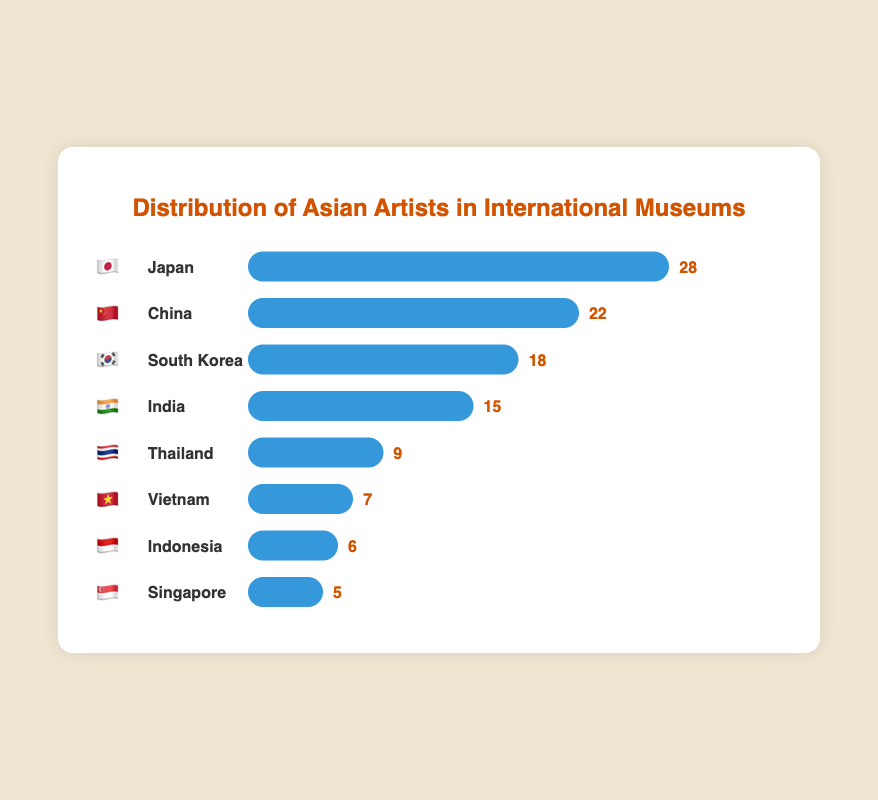How many artists from Japan are featured in international museums? The plot shows a bar with the label "Japan" and an emoji 🇯🇵. Next to this bar, it shows the number 28.
Answer: 28 What's the difference in the number of artists between China and South Korea? The figure shows that China has 22 artists and South Korea has 18 artists. The difference is calculated as 22 - 18 = 4.
Answer: 4 Which country has the least number of artists featured in international museums? The country with the smallest bar is Singapore, and the bar is labeled with the number 5 next to the emoji 🇸🇬.
Answer: Singapore How many more artists from Japan are featured compared to Thailand? Japan has 28 artists, and Thailand has 9 artists. The difference is 28 - 9 = 19.
Answer: 19 Which two countries have a combined total of 33 artists? By examining the numbers next to each bar, the sum of artists from India and Vietnam (15 + 7 = 22) and Indonesia and Singapore (6 + 5 = 11). The pair that add up to 33 is Japan (28) and Vietnam (7) respectively.
Answer: Japan and Vietnam How many artists are featured from all the countries combined? Summing the artists from all countries shown: 28 (Japan) + 22 (China) + 18 (South Korea) + 15 (India) + 9 (Thailand) + 7 (Vietnam) + 6 (Indonesia) + 5 (Singapore) = 110.
Answer: 110 Which country has more artists featured: Vietnam or Indonesia? The bar labeled Vietnam is followed by the number 7, and the bar labeled Indonesia is followed by the number 6. Since 7 is greater than 6, Vietnam has more artists.
Answer: Vietnam What is the average number of artists featured per country? The total number of artists from all the countries is 110. There are 8 countries listed. Therefore, the average is 110 / 8 = 13.75.
Answer: 13.75 Which three countries have the highest number of artists featured in international museums? The three countries with the largest bars are Japan (28), China (22), and South Korea (18).
Answer: Japan, China, South Korea 